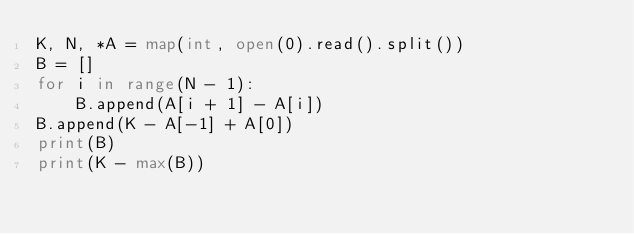<code> <loc_0><loc_0><loc_500><loc_500><_Python_>K, N, *A = map(int, open(0).read().split())
B = []
for i in range(N - 1):
    B.append(A[i + 1] - A[i])
B.append(K - A[-1] + A[0])
print(B)
print(K - max(B))
</code> 